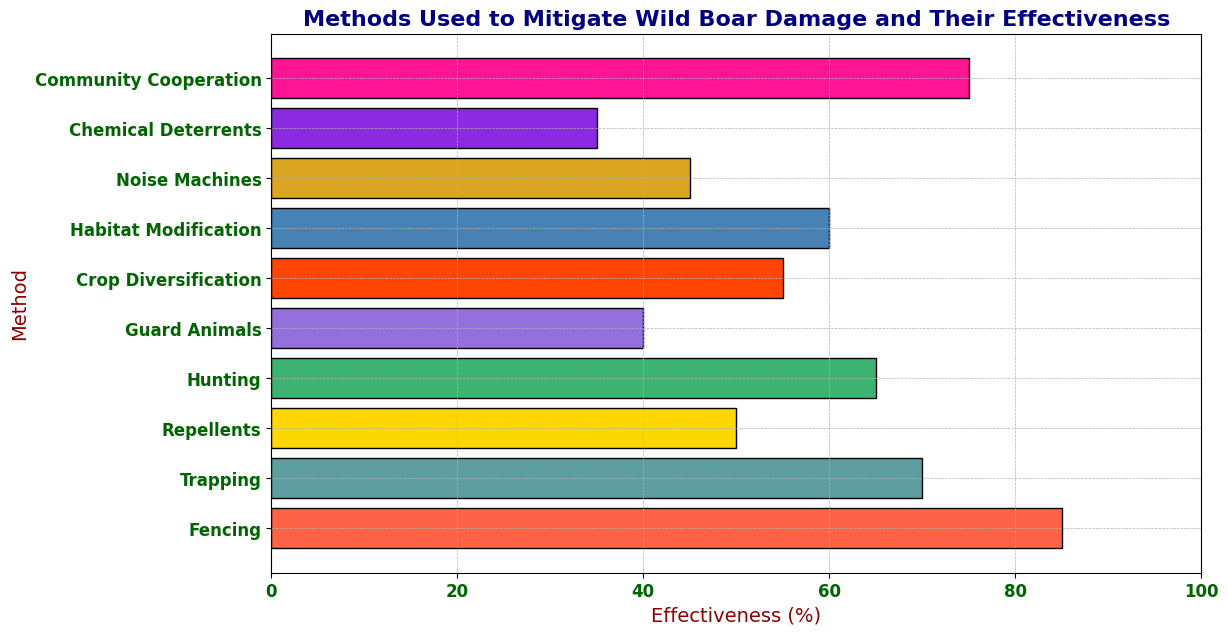How effective is the "Community Cooperation" method in mitigating wild boar damage? The "Community Cooperation" method is represented by a bar on the plot. By looking at the height/length of the bar next to "Community Cooperation," we see that it reaches up to 75% effectiveness.
Answer: 75% Which method is the least effective in mitigating wild boar damage? To find the least effective method, we look for the shortest bar in the chart. The bar representing "Chemical Deterrents" is the shortest, indicating it has the lowest effectiveness at 35%.
Answer: Chemical Deterrents How much more effective is "Fencing" compared to "Guard Animals"? To determine the difference, we note the effectiveness of "Fencing" (85%) and "Guard Animals" (40%). Subtracting these values (85 - 40), we find that "Fencing" is 45% more effective than "Guard Animals."
Answer: 45% Which methods have effectiveness greater than 60%? By scanning the plot, we identify the bars that extend beyond the 60% mark. The methods with effectiveness greater than 60% are "Fencing" (85%), "Trapping" (70%), "Hunting" (65%), and "Community Cooperation" (75%).
Answer: Fencing, Trapping, Hunting, Community Cooperation What is the average effectiveness of "Repellents," "Noise Machines," and "Chemical Deterrents"? To find the average, sum the effectiveness values of these methods: Repellents (50%), Noise Machines (45%), Chemical Deterrents (35%). The total is 130%. Dividing by the number of methods (3), the average effectiveness is approximately 43.3%.
Answer: 43.3% Is "Crop Diversification" more effective than "Habitat Modification"? Comparing the heights/lengths of the bars for "Crop Diversification" (55%) and "Habitat Modification" (60%), we observe that "Habitat Modification" has a higher value. Therefore, "Crop Diversification" is not more effective.
Answer: No What is the median effectiveness of all the methods shown? To find the median, first list the effectiveness values in ascending order: 35, 40, 45, 50, 55, 60, 65, 70, 75, 85. Since there are 10 values, the median is the average of the 5th and 6th values: (55 + 60) / 2 = 57.5%.
Answer: 57.5% Which methods have bars that are colored green? The only bar that is green in color (monitor visually) represents the method "Hunting."
Answer: Hunting 